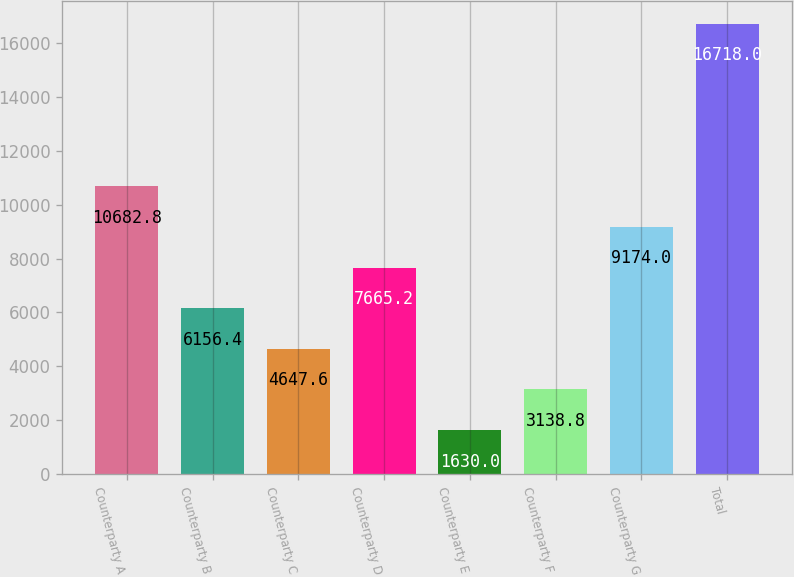Convert chart. <chart><loc_0><loc_0><loc_500><loc_500><bar_chart><fcel>Counterparty A<fcel>Counterparty B<fcel>Counterparty C<fcel>Counterparty D<fcel>Counterparty E<fcel>Counterparty F<fcel>Counterparty G<fcel>Total<nl><fcel>10682.8<fcel>6156.4<fcel>4647.6<fcel>7665.2<fcel>1630<fcel>3138.8<fcel>9174<fcel>16718<nl></chart> 